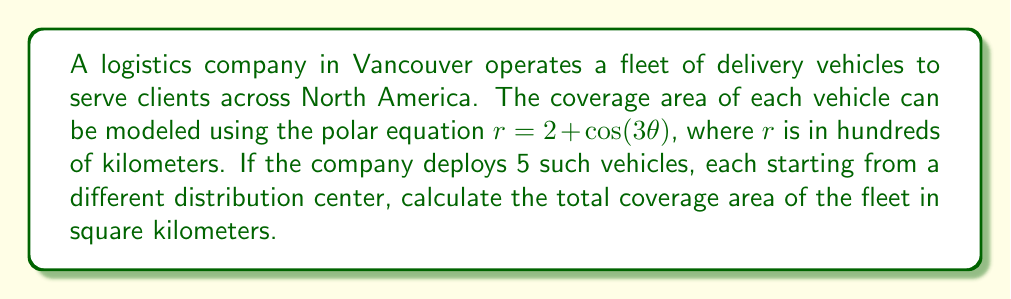What is the answer to this math problem? To solve this problem, we need to follow these steps:

1) First, we need to calculate the area covered by one vehicle. The area of a polar region is given by the formula:

   $$A = \frac{1}{2} \int_{0}^{2\pi} r^2 d\theta$$

2) In our case, $r = 2 + \cos(3\theta)$, so we need to calculate:

   $$A = \frac{1}{2} \int_{0}^{2\pi} (2 + \cos(3\theta))^2 d\theta$$

3) Expand the integrand:
   $$(2 + \cos(3\theta))^2 = 4 + 4\cos(3\theta) + \cos^2(3\theta)$$

4) Now our integral becomes:

   $$A = \frac{1}{2} \int_{0}^{2\pi} (4 + 4\cos(3\theta) + \cos^2(3\theta)) d\theta$$

5) Integrate each term:
   
   - $\int_{0}^{2\pi} 4 d\theta = 4(2\pi) = 8\pi$
   - $\int_{0}^{2\pi} 4\cos(3\theta) d\theta = \frac{4}{3}[\sin(3\theta)]_{0}^{2\pi} = 0$
   - $\int_{0}^{2\pi} \cos^2(3\theta) d\theta = \int_{0}^{2\pi} \frac{1+\cos(6\theta)}{2} d\theta = \pi$

6) Sum up the results:

   $$A = \frac{1}{2}(8\pi + 0 + \pi) = \frac{9\pi}{2}$$

7) This area is in units of (100 km)^2. To convert to km^2, multiply by 10,000:

   $$A_{km^2} = \frac{9\pi}{2} \cdot 10,000 = 45,000\pi$$

8) For 5 vehicles, multiply this area by 5:

   $$A_{total} = 5 \cdot 45,000\pi = 225,000\pi$$
Answer: The total coverage area of the fleet is $225,000\pi$ square kilometers, or approximately 706,858 square kilometers. 